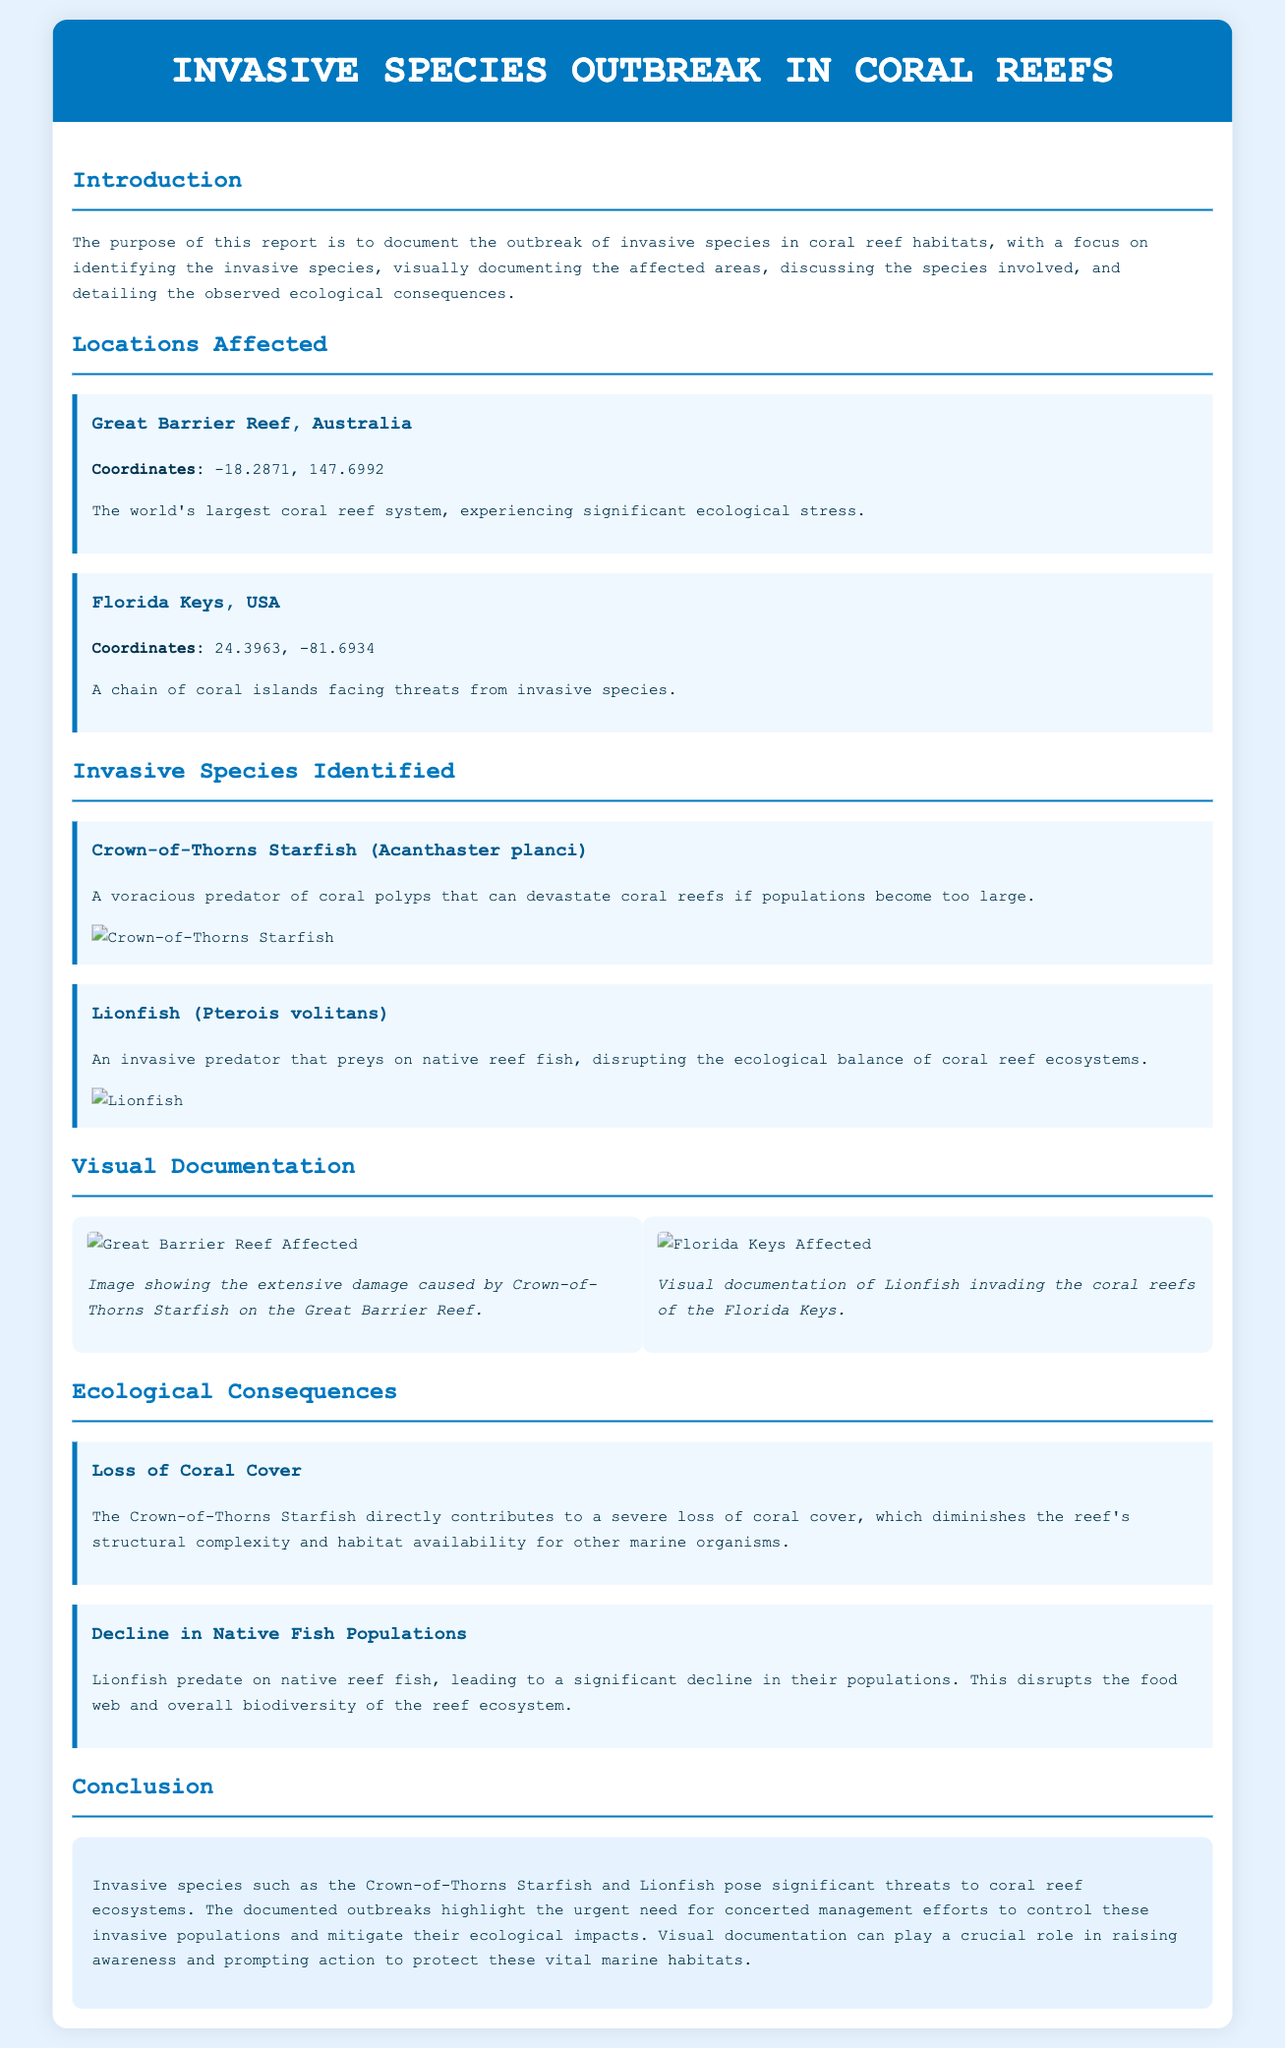What is the title of the report? The title of the report is found in the header section, which gives an overview of its main focus.
Answer: Invasive Species Outbreak in Coral Reefs What species is identified as a predator of coral polyps? The document discusses a species that has a significant negative impact on coral reefs due to its predatory behavior.
Answer: Crown-of-Thorns Starfish What are the coordinates for the Florida Keys? The coordinates are listed under the "Locations Affected" section, specifically for this location.
Answer: 24.3963, -81.6934 What consequence is caused by the Lionfish? The report details the ecological consequences of the Lionfish on native fish populations.
Answer: Decline in Native Fish Populations What image documents the Great Barrier Reef's affected area? A specific image is referenced to visually represent the damage caused at the Great Barrier Reef.
Answer: https://example.com/images/great-barrier-reef-affected.jpg How does the Crown-of-Thorns Starfish affect coral cover? The report explains the impact of this invasive species on coral cover within the ecosystem.
Answer: Severe loss of coral cover What is stated as essential for protecting coral reefs? The conclusion emphasizes what is necessary to address the threats posed by invasive species.
Answer: Concerted management efforts 